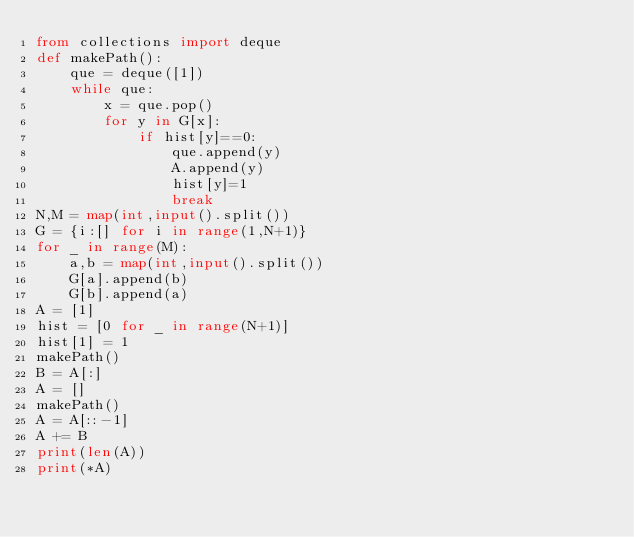Convert code to text. <code><loc_0><loc_0><loc_500><loc_500><_Python_>from collections import deque
def makePath():
    que = deque([1])
    while que:
        x = que.pop()
        for y in G[x]:
            if hist[y]==0:
                que.append(y)
                A.append(y)
                hist[y]=1
                break
N,M = map(int,input().split())
G = {i:[] for i in range(1,N+1)}
for _ in range(M):
    a,b = map(int,input().split())
    G[a].append(b)
    G[b].append(a)
A = [1]
hist = [0 for _ in range(N+1)]
hist[1] = 1
makePath()
B = A[:]
A = []
makePath()
A = A[::-1]
A += B
print(len(A))
print(*A)</code> 